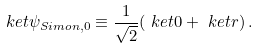<formula> <loc_0><loc_0><loc_500><loc_500>\ k e t { \psi _ { S i m o n , 0 } } \equiv \frac { 1 } { \sqrt { 2 } } ( \ k e t { 0 } + \ k e t { r } ) \, .</formula> 